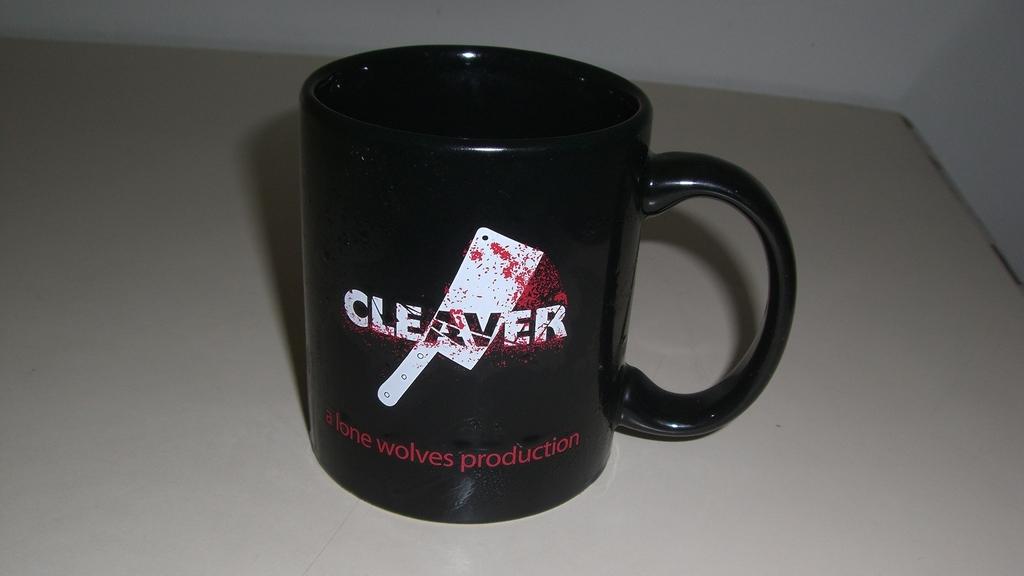Who produced this mug?
Provide a short and direct response. Lone wolves. What does the mug say?
Offer a terse response. Cleaver. 